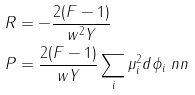Convert formula to latex. <formula><loc_0><loc_0><loc_500><loc_500>R & = - \frac { 2 ( F - 1 ) } { w ^ { 2 } Y } \\ P & = \frac { 2 ( F - 1 ) } { w Y } \sum _ { i } \mu ^ { 2 } _ { i } d \phi _ { i } \ n n</formula> 